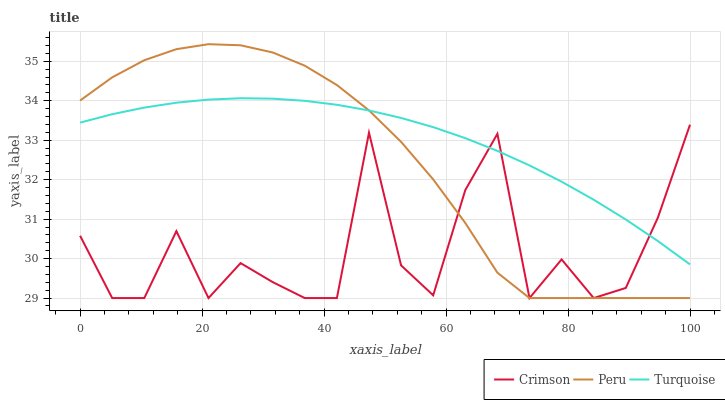Does Crimson have the minimum area under the curve?
Answer yes or no. Yes. Does Turquoise have the maximum area under the curve?
Answer yes or no. Yes. Does Peru have the minimum area under the curve?
Answer yes or no. No. Does Peru have the maximum area under the curve?
Answer yes or no. No. Is Turquoise the smoothest?
Answer yes or no. Yes. Is Crimson the roughest?
Answer yes or no. Yes. Is Peru the smoothest?
Answer yes or no. No. Is Peru the roughest?
Answer yes or no. No. Does Crimson have the lowest value?
Answer yes or no. Yes. Does Turquoise have the lowest value?
Answer yes or no. No. Does Peru have the highest value?
Answer yes or no. Yes. Does Turquoise have the highest value?
Answer yes or no. No. Does Peru intersect Turquoise?
Answer yes or no. Yes. Is Peru less than Turquoise?
Answer yes or no. No. Is Peru greater than Turquoise?
Answer yes or no. No. 